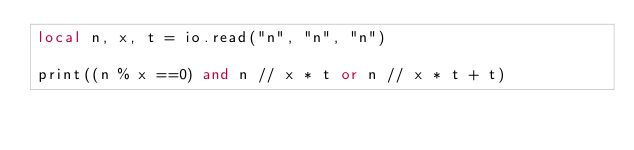Convert code to text. <code><loc_0><loc_0><loc_500><loc_500><_Lua_>local n, x, t = io.read("n", "n", "n")

print((n % x ==0) and n // x * t or n // x * t + t)
</code> 